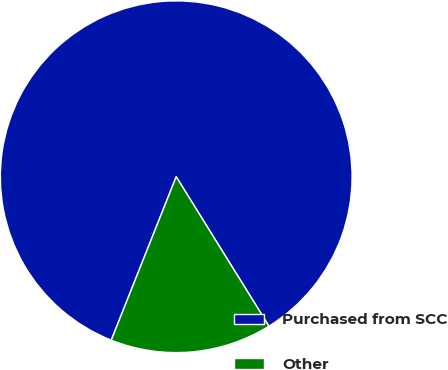Convert chart to OTSL. <chart><loc_0><loc_0><loc_500><loc_500><pie_chart><fcel>Purchased from SCC<fcel>Other<nl><fcel>85.14%<fcel>14.86%<nl></chart> 